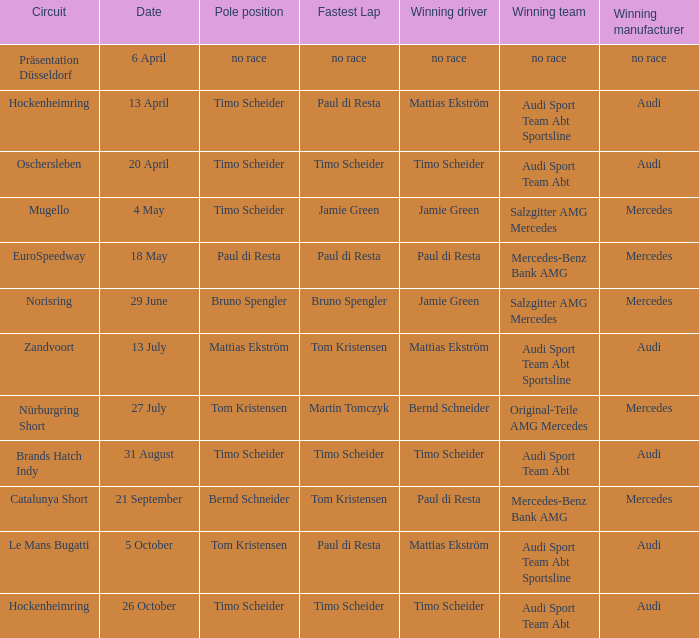Who is the victorious driver of the race with no race as the triumphant manufacturer? No race. 